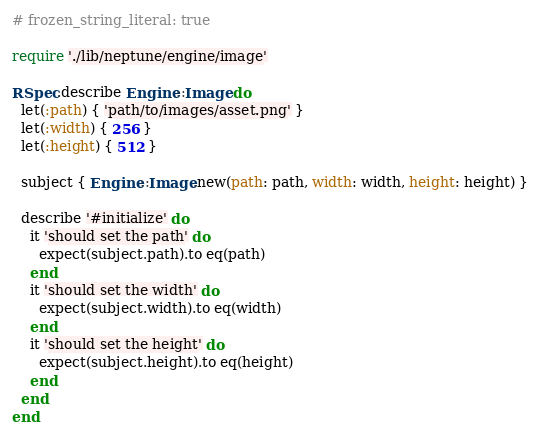<code> <loc_0><loc_0><loc_500><loc_500><_Ruby_># frozen_string_literal: true

require './lib/neptune/engine/image'

RSpec.describe Engine::Image do
  let(:path) { 'path/to/images/asset.png' }
  let(:width) { 256 }
  let(:height) { 512 }

  subject { Engine::Image.new(path: path, width: width, height: height) }

  describe '#initialize' do
    it 'should set the path' do
      expect(subject.path).to eq(path)
    end
    it 'should set the width' do
      expect(subject.width).to eq(width)
    end
    it 'should set the height' do
      expect(subject.height).to eq(height)
    end
  end
end
</code> 